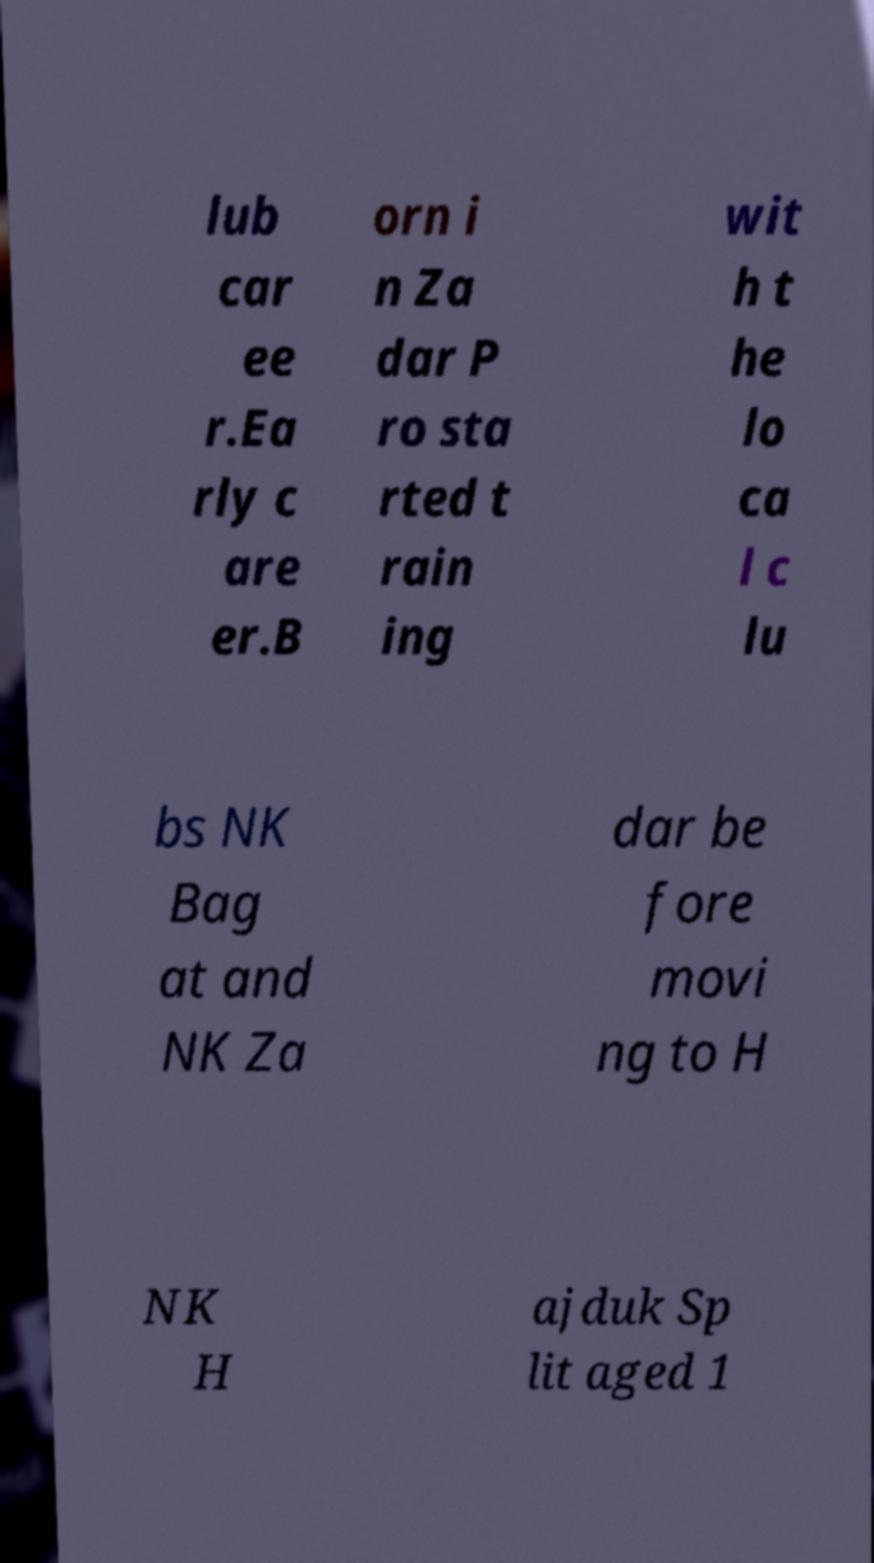Could you assist in decoding the text presented in this image and type it out clearly? lub car ee r.Ea rly c are er.B orn i n Za dar P ro sta rted t rain ing wit h t he lo ca l c lu bs NK Bag at and NK Za dar be fore movi ng to H NK H ajduk Sp lit aged 1 